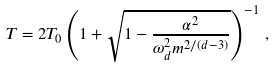Convert formula to latex. <formula><loc_0><loc_0><loc_500><loc_500>T = 2 T _ { 0 } \left ( 1 + \sqrt { 1 - \frac { \alpha ^ { 2 } } { \omega _ { d } ^ { 2 } m ^ { 2 / ( d - 3 ) } } } \right ) ^ { - 1 } \, ,</formula> 